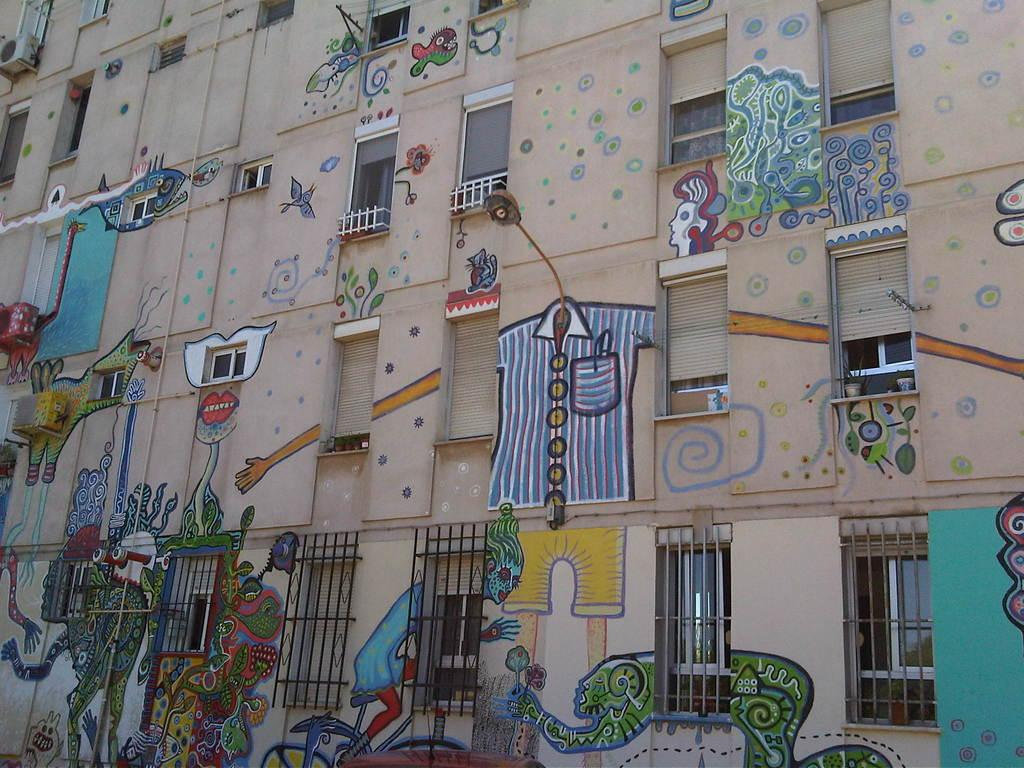What structure is present in the image? There is a building in the image. What artistic element is featured on the building? There is a painting on the building. What architectural feature is present on the building? There are windows on the building. What type of bells can be heard ringing in the image? There are no bells present in the image, and therefore no such sound can be heard. What is the building rolling on in the image? The building is stationary in the image and does not appear to be rolling on anything. How many screws can be seen holding the painting on the building? There is no information about screws in the image; the painting's attachment method is not mentioned. 